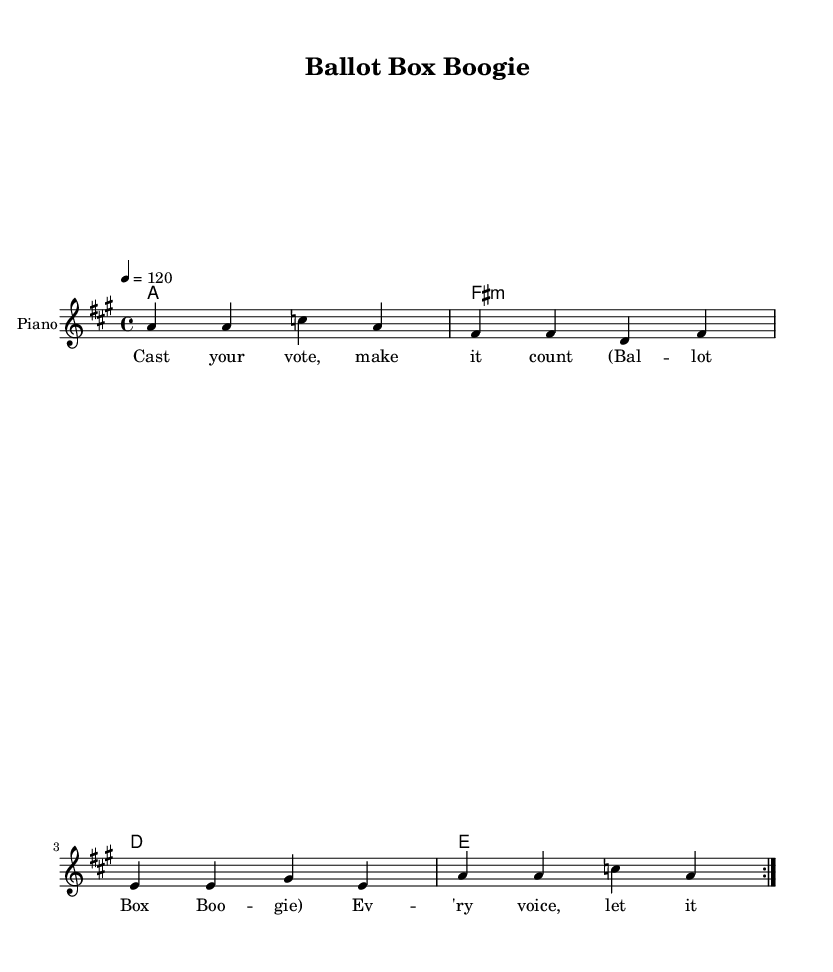What is the key signature of this music? The key signature indicated in the global section of the code is A major, which contains three sharps: F#, C#, and G#.
Answer: A major What is the time signature of this music? The time signature is shown in the global section where it states 4/4, meaning there are four beats per measure and the quarter note gets one beat.
Answer: 4/4 What is the tempo marking for this music? The tempo is specified in the global section as "4 = 120," meaning there are 120 beats per minute, which indicates a lively and upbeat tempo typical of disco music.
Answer: 120 How many times is the melody repeated? The melody is marked with \repeat volta 2, which indicates that it is played two times as part of a repeated section, usually found in many forms of popular music, including disco.
Answer: 2 What instrument is indicated for this score? The instrument for the score is specified in the Staff section with the label "Piano," which suggests that the music is arranged for piano performance, common in disco arrangements.
Answer: Piano What is the title of this piece? The title is found in the header section of the code, where it states "Ballot Box Boogie," reflecting the theme of the lyrics relating to voting rights and election processes.
Answer: Ballot Box Boogie What type of chords are indicated for this music? The chord mode indicates a progression of A major, F# minor, D major, and E major chords, which are common in disco songs for creating a groovy and danceable sound.
Answer: A, F# minor, D, E 